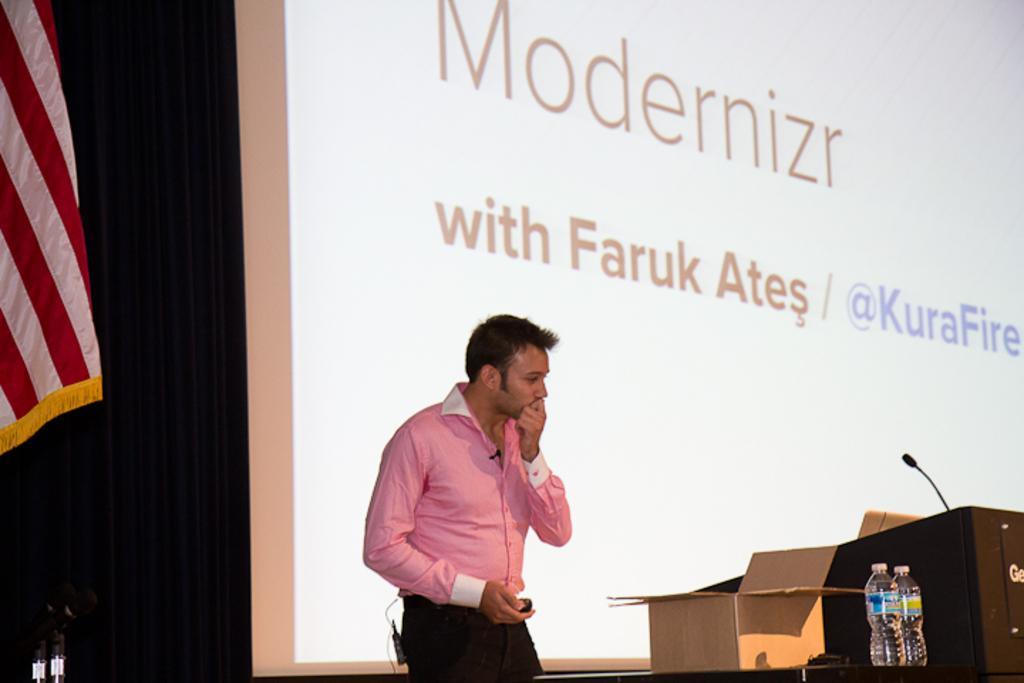Can you describe this image briefly? In this image we can see a person standing beside a table which contains a cardboard box and two bottles on it. On the right side we can see a speaker stand with a mic. On the backside we can see the projector and the flag. 